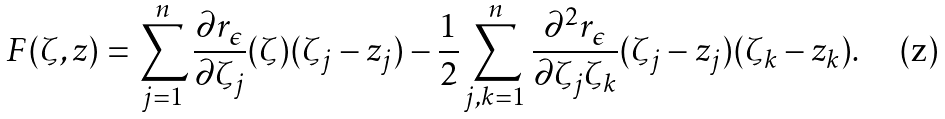Convert formula to latex. <formula><loc_0><loc_0><loc_500><loc_500>F ( \zeta , z ) = \sum _ { j = 1 } ^ { n } \frac { \partial r _ { \epsilon } } { \partial \zeta _ { j } } ( \zeta ) ( \zeta _ { j } - z _ { j } ) - \frac { 1 } { 2 } \sum _ { j , k = 1 } ^ { n } \frac { \partial ^ { 2 } r _ { \epsilon } } { \partial \zeta _ { j } \zeta _ { k } } ( \zeta _ { j } - z _ { j } ) ( \zeta _ { k } - z _ { k } ) .</formula> 